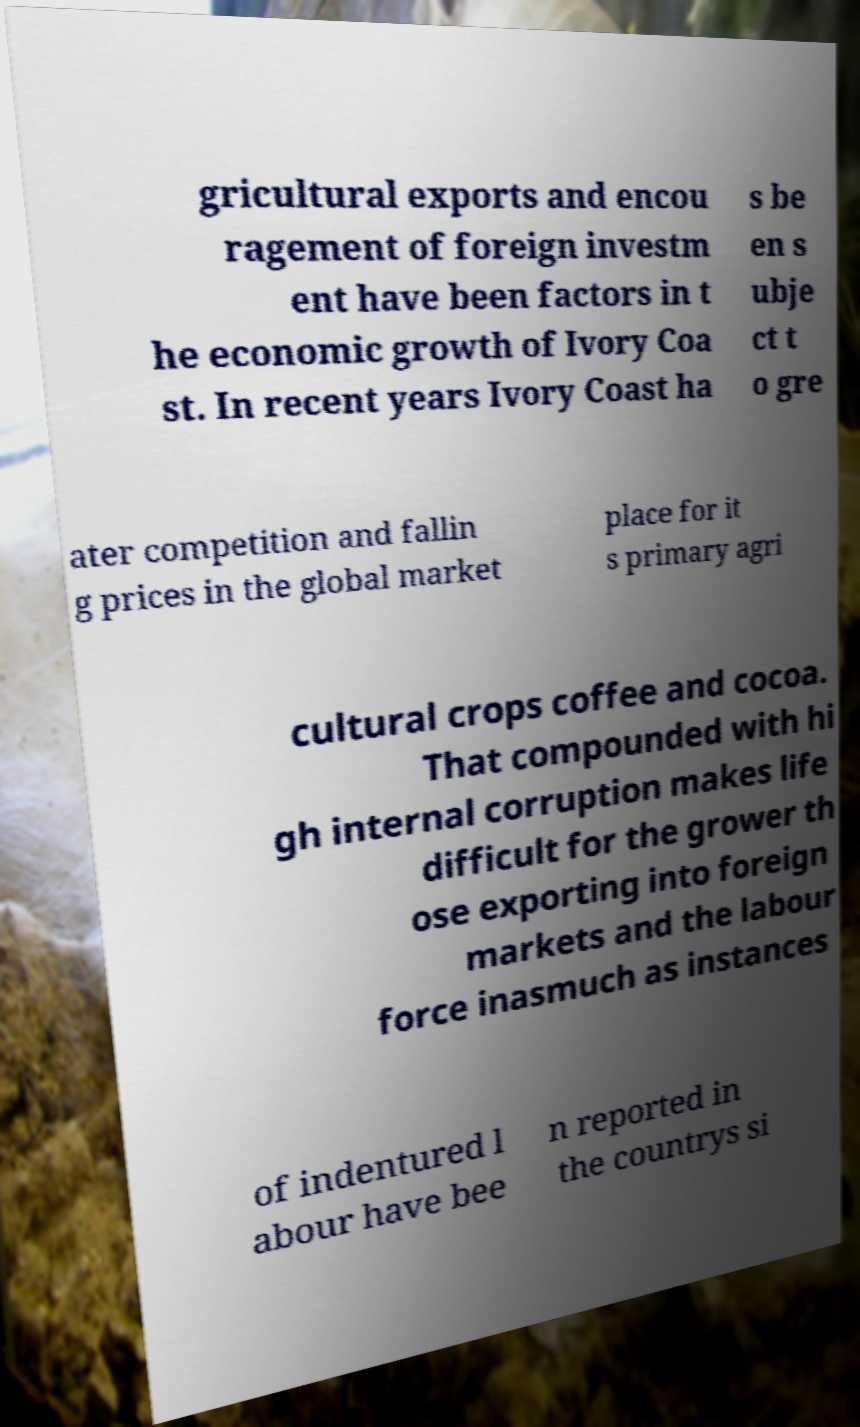Please identify and transcribe the text found in this image. gricultural exports and encou ragement of foreign investm ent have been factors in t he economic growth of Ivory Coa st. In recent years Ivory Coast ha s be en s ubje ct t o gre ater competition and fallin g prices in the global market place for it s primary agri cultural crops coffee and cocoa. That compounded with hi gh internal corruption makes life difficult for the grower th ose exporting into foreign markets and the labour force inasmuch as instances of indentured l abour have bee n reported in the countrys si 